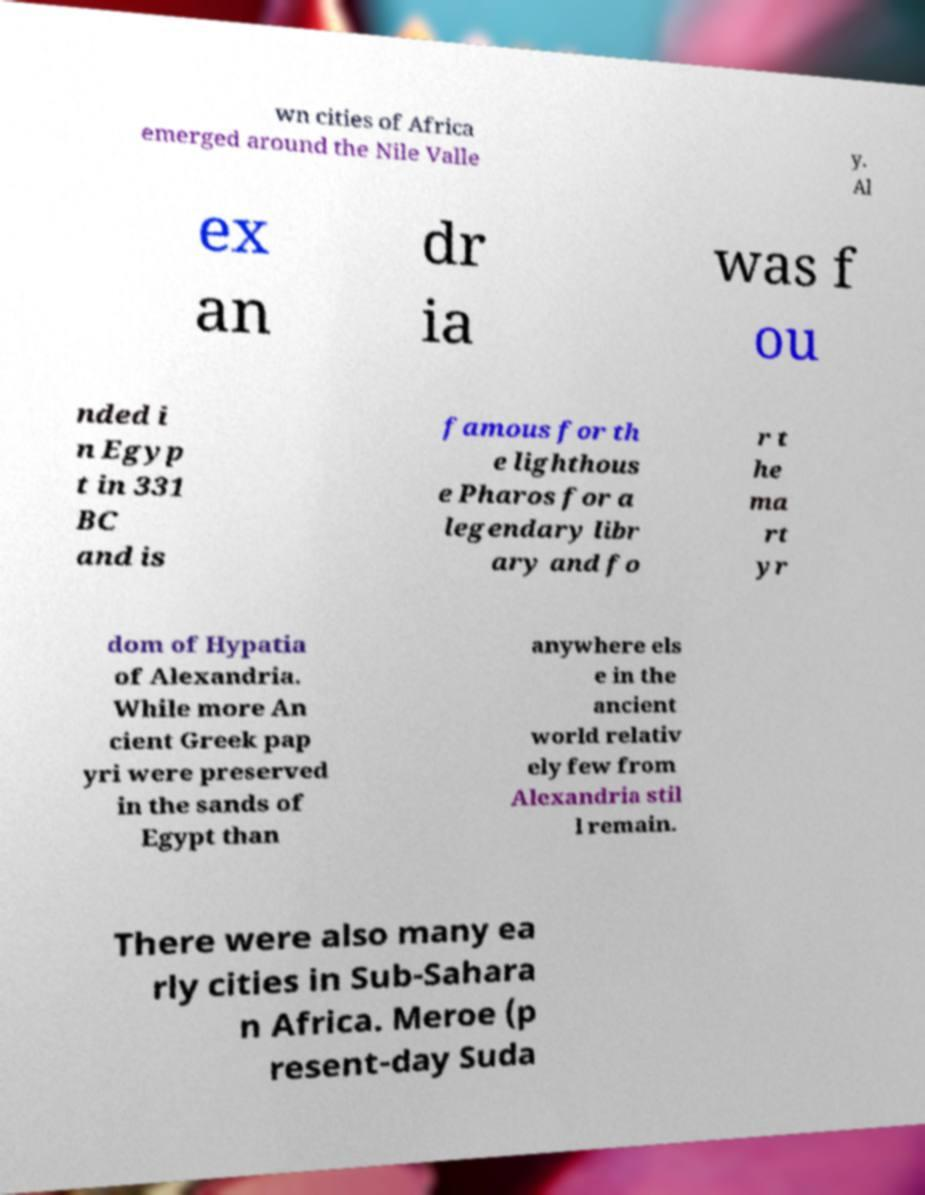I need the written content from this picture converted into text. Can you do that? wn cities of Africa emerged around the Nile Valle y. Al ex an dr ia was f ou nded i n Egyp t in 331 BC and is famous for th e lighthous e Pharos for a legendary libr ary and fo r t he ma rt yr dom of Hypatia of Alexandria. While more An cient Greek pap yri were preserved in the sands of Egypt than anywhere els e in the ancient world relativ ely few from Alexandria stil l remain. There were also many ea rly cities in Sub-Sahara n Africa. Meroe (p resent-day Suda 